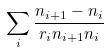<formula> <loc_0><loc_0><loc_500><loc_500>\sum _ { i } \frac { n _ { i + 1 } - n _ { i } } { r _ { i } n _ { i + 1 } n _ { i } }</formula> 